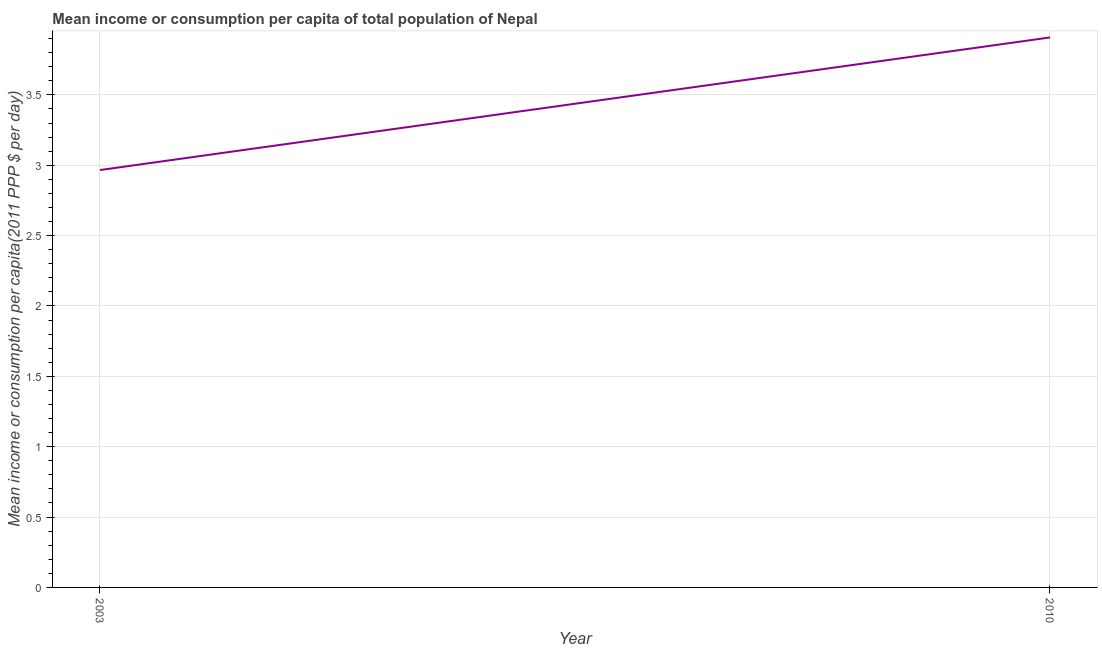What is the mean income or consumption in 2003?
Your response must be concise. 2.97. Across all years, what is the maximum mean income or consumption?
Keep it short and to the point. 3.91. Across all years, what is the minimum mean income or consumption?
Give a very brief answer. 2.97. In which year was the mean income or consumption maximum?
Keep it short and to the point. 2010. In which year was the mean income or consumption minimum?
Provide a succinct answer. 2003. What is the sum of the mean income or consumption?
Provide a succinct answer. 6.87. What is the difference between the mean income or consumption in 2003 and 2010?
Make the answer very short. -0.94. What is the average mean income or consumption per year?
Offer a very short reply. 3.44. What is the median mean income or consumption?
Your response must be concise. 3.44. Do a majority of the years between 2010 and 2003 (inclusive) have mean income or consumption greater than 0.9 $?
Your answer should be compact. No. What is the ratio of the mean income or consumption in 2003 to that in 2010?
Give a very brief answer. 0.76. In how many years, is the mean income or consumption greater than the average mean income or consumption taken over all years?
Provide a short and direct response. 1. How many years are there in the graph?
Offer a very short reply. 2. Does the graph contain any zero values?
Your answer should be compact. No. Does the graph contain grids?
Ensure brevity in your answer.  Yes. What is the title of the graph?
Ensure brevity in your answer.  Mean income or consumption per capita of total population of Nepal. What is the label or title of the Y-axis?
Your response must be concise. Mean income or consumption per capita(2011 PPP $ per day). What is the Mean income or consumption per capita(2011 PPP $ per day) of 2003?
Your answer should be very brief. 2.97. What is the Mean income or consumption per capita(2011 PPP $ per day) in 2010?
Keep it short and to the point. 3.91. What is the difference between the Mean income or consumption per capita(2011 PPP $ per day) in 2003 and 2010?
Give a very brief answer. -0.94. What is the ratio of the Mean income or consumption per capita(2011 PPP $ per day) in 2003 to that in 2010?
Your answer should be compact. 0.76. 